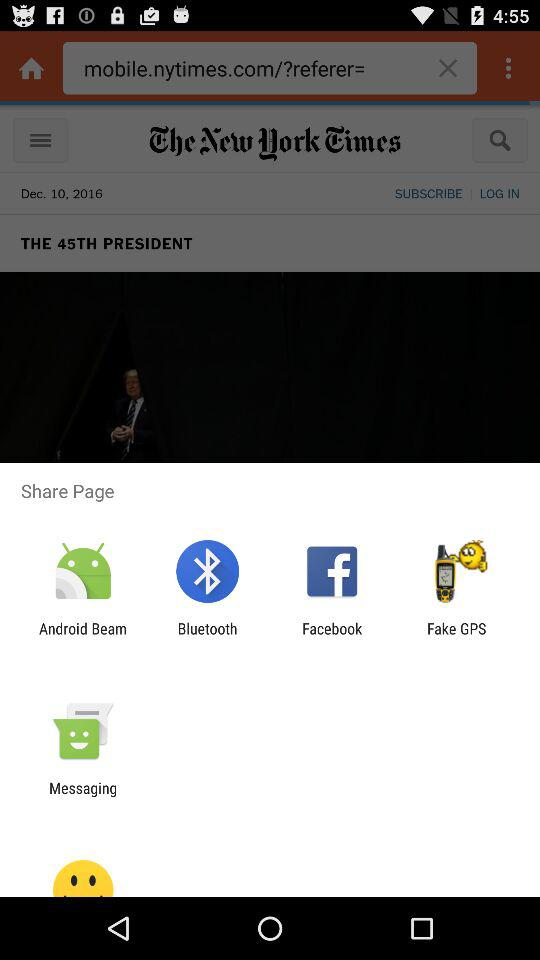What are the options available for sharing the page? The available options are "Android Beam", "Bluetooth", "Facebook", "Fake GPS" and "Messaging". 